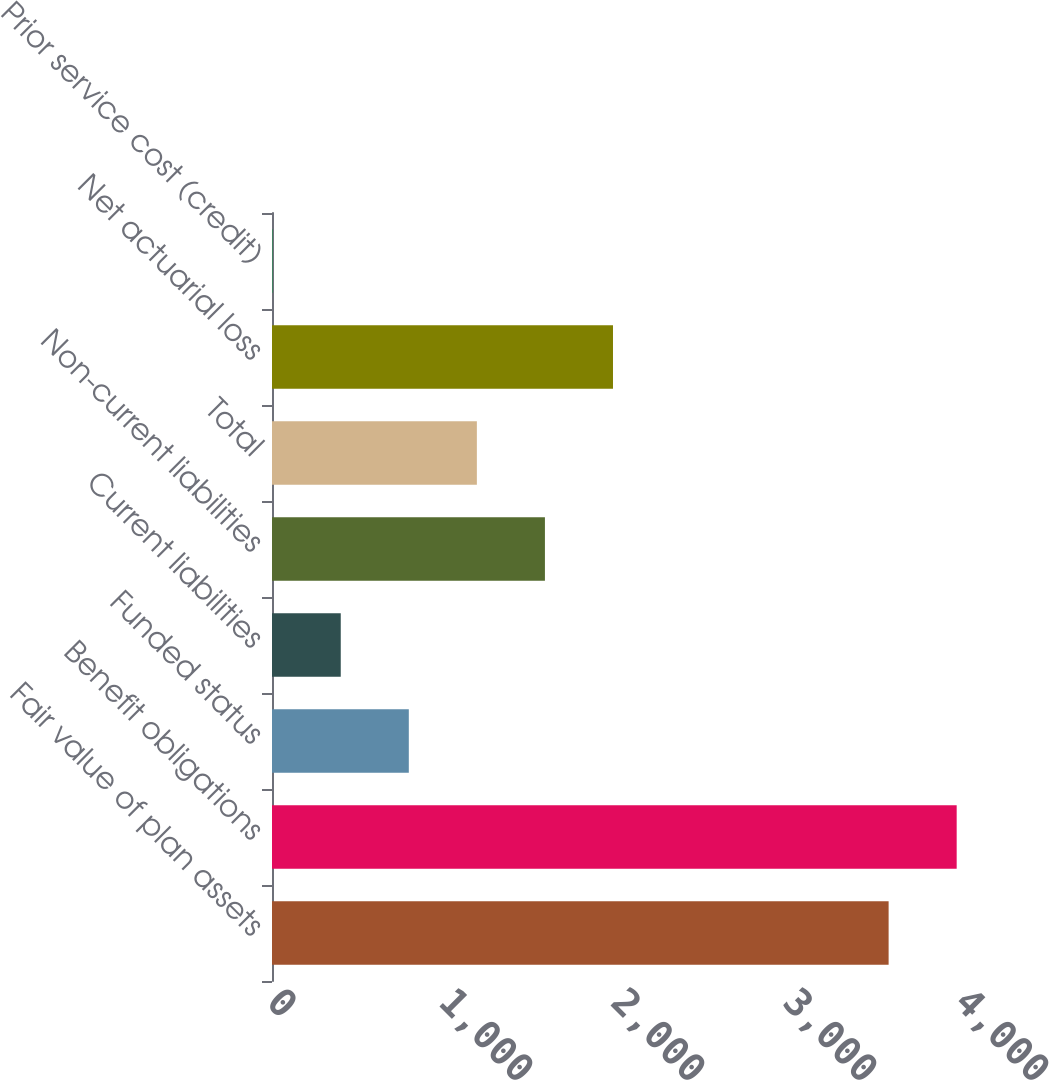<chart> <loc_0><loc_0><loc_500><loc_500><bar_chart><fcel>Fair value of plan assets<fcel>Benefit obligations<fcel>Funded status<fcel>Current liabilities<fcel>Non-current liabilities<fcel>Total<fcel>Net actuarial loss<fcel>Prior service cost (credit)<nl><fcel>3585<fcel>3980.7<fcel>795.4<fcel>399.7<fcel>1586.8<fcel>1191.1<fcel>1982.5<fcel>4<nl></chart> 